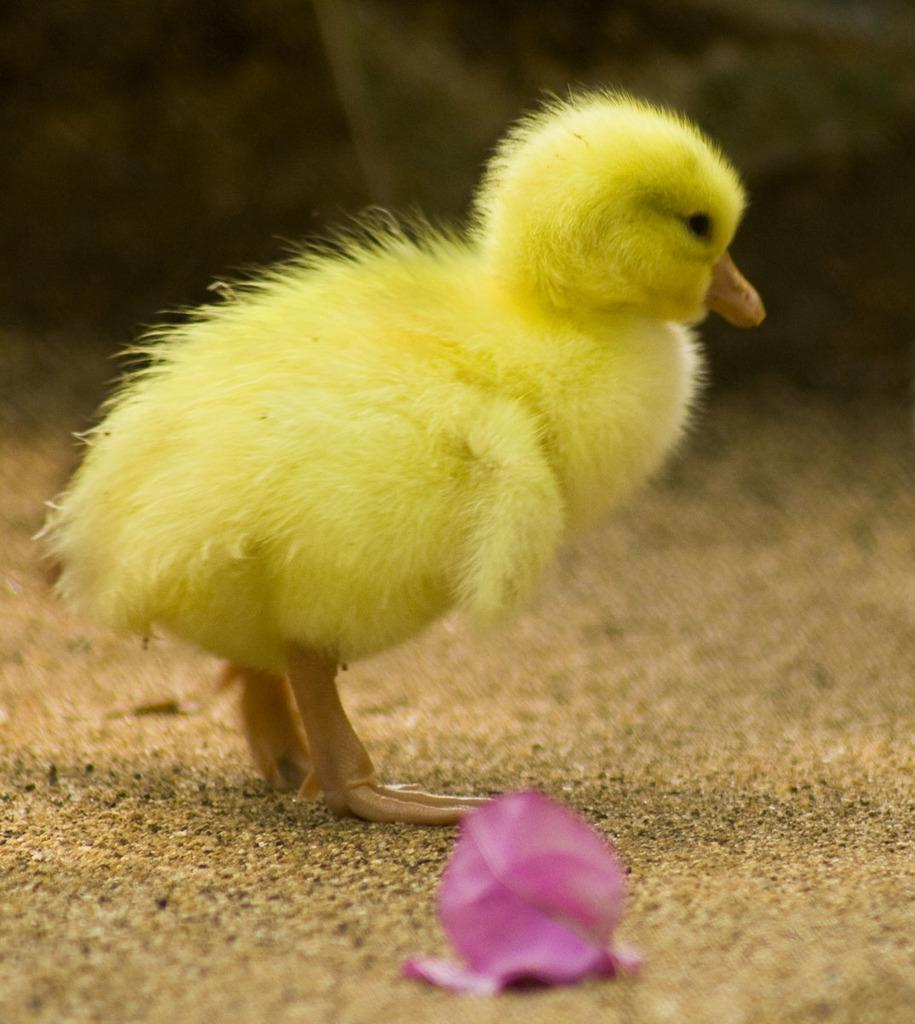What type of animal is in the foreground of the image? There is a yellow color chicken in the foreground of the image. Where is the chicken located in the image? The chicken is on the ground. What other object can be seen in the image? There is a flower in the image. When was the image taken? The image was taken during the day. What is the chance of the chicken walking on its tail in the image? Chickens do not walk on their tails, so this scenario is not present in the image. 